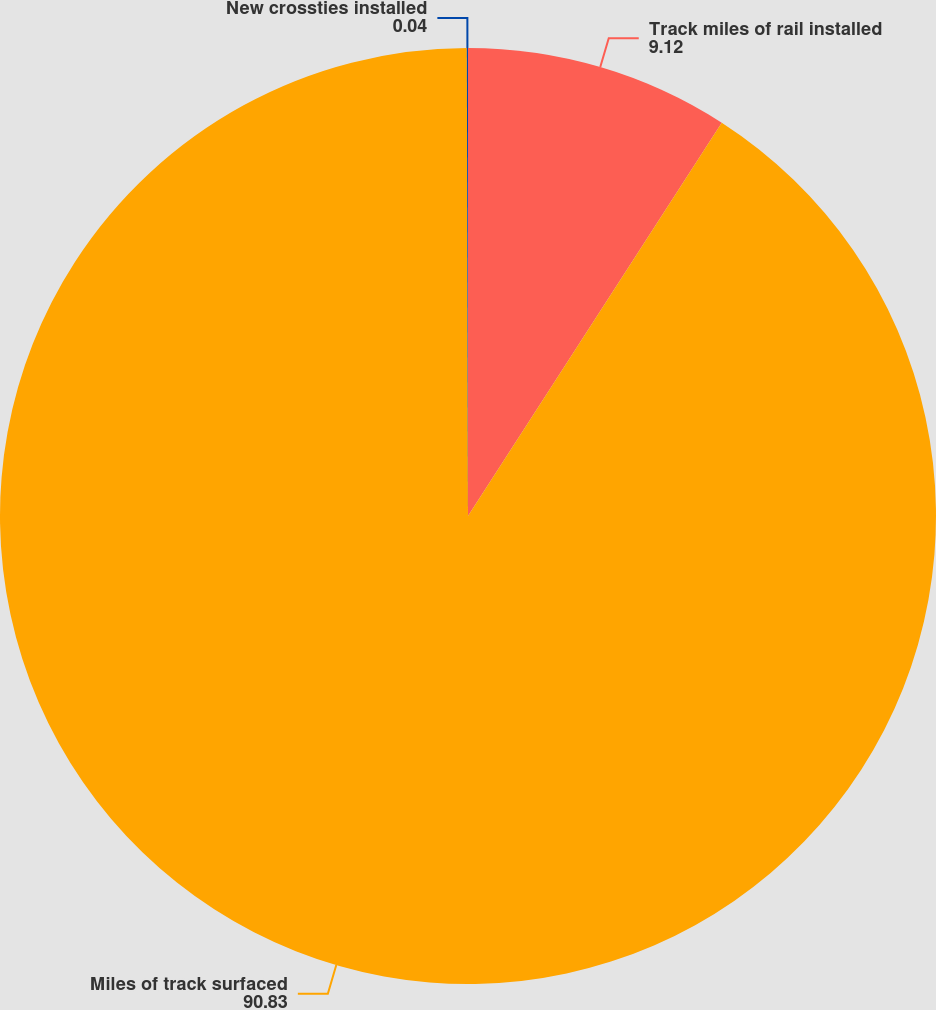<chart> <loc_0><loc_0><loc_500><loc_500><pie_chart><fcel>Track miles of rail installed<fcel>Miles of track surfaced<fcel>New crossties installed<nl><fcel>9.12%<fcel>90.83%<fcel>0.04%<nl></chart> 